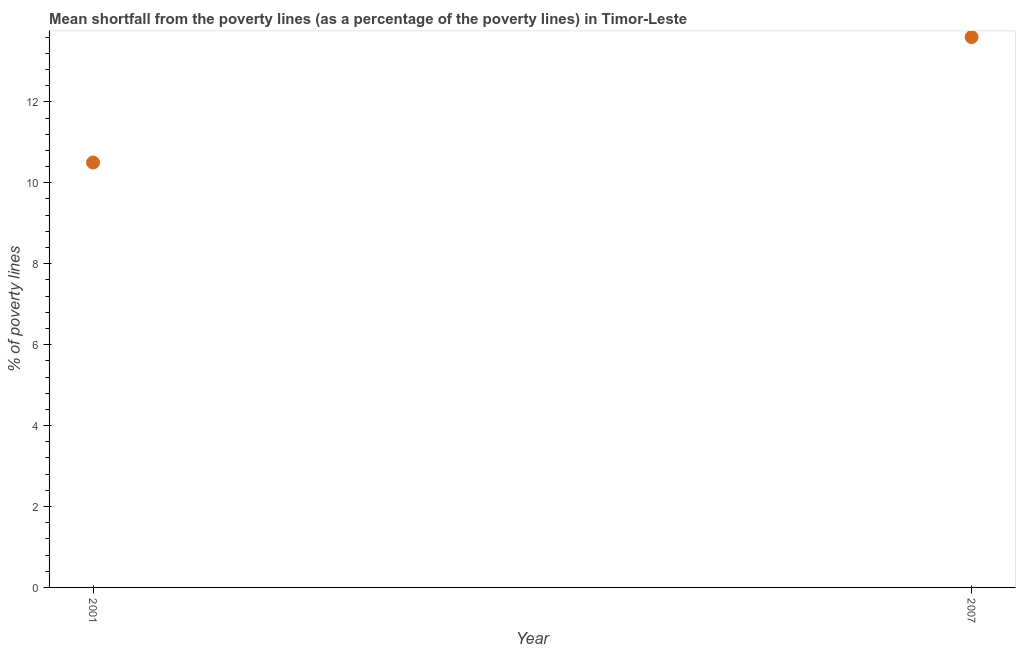In which year was the poverty gap at national poverty lines maximum?
Offer a terse response. 2007. What is the sum of the poverty gap at national poverty lines?
Keep it short and to the point. 24.1. What is the difference between the poverty gap at national poverty lines in 2001 and 2007?
Ensure brevity in your answer.  -3.1. What is the average poverty gap at national poverty lines per year?
Give a very brief answer. 12.05. What is the median poverty gap at national poverty lines?
Ensure brevity in your answer.  12.05. What is the ratio of the poverty gap at national poverty lines in 2001 to that in 2007?
Offer a very short reply. 0.77. Is the poverty gap at national poverty lines in 2001 less than that in 2007?
Make the answer very short. Yes. Does the poverty gap at national poverty lines monotonically increase over the years?
Make the answer very short. Yes. How many dotlines are there?
Your answer should be very brief. 1. How many years are there in the graph?
Provide a short and direct response. 2. What is the difference between two consecutive major ticks on the Y-axis?
Your answer should be compact. 2. Does the graph contain any zero values?
Your response must be concise. No. Does the graph contain grids?
Give a very brief answer. No. What is the title of the graph?
Provide a short and direct response. Mean shortfall from the poverty lines (as a percentage of the poverty lines) in Timor-Leste. What is the label or title of the Y-axis?
Your response must be concise. % of poverty lines. What is the % of poverty lines in 2001?
Your response must be concise. 10.5. What is the % of poverty lines in 2007?
Offer a terse response. 13.6. What is the ratio of the % of poverty lines in 2001 to that in 2007?
Keep it short and to the point. 0.77. 